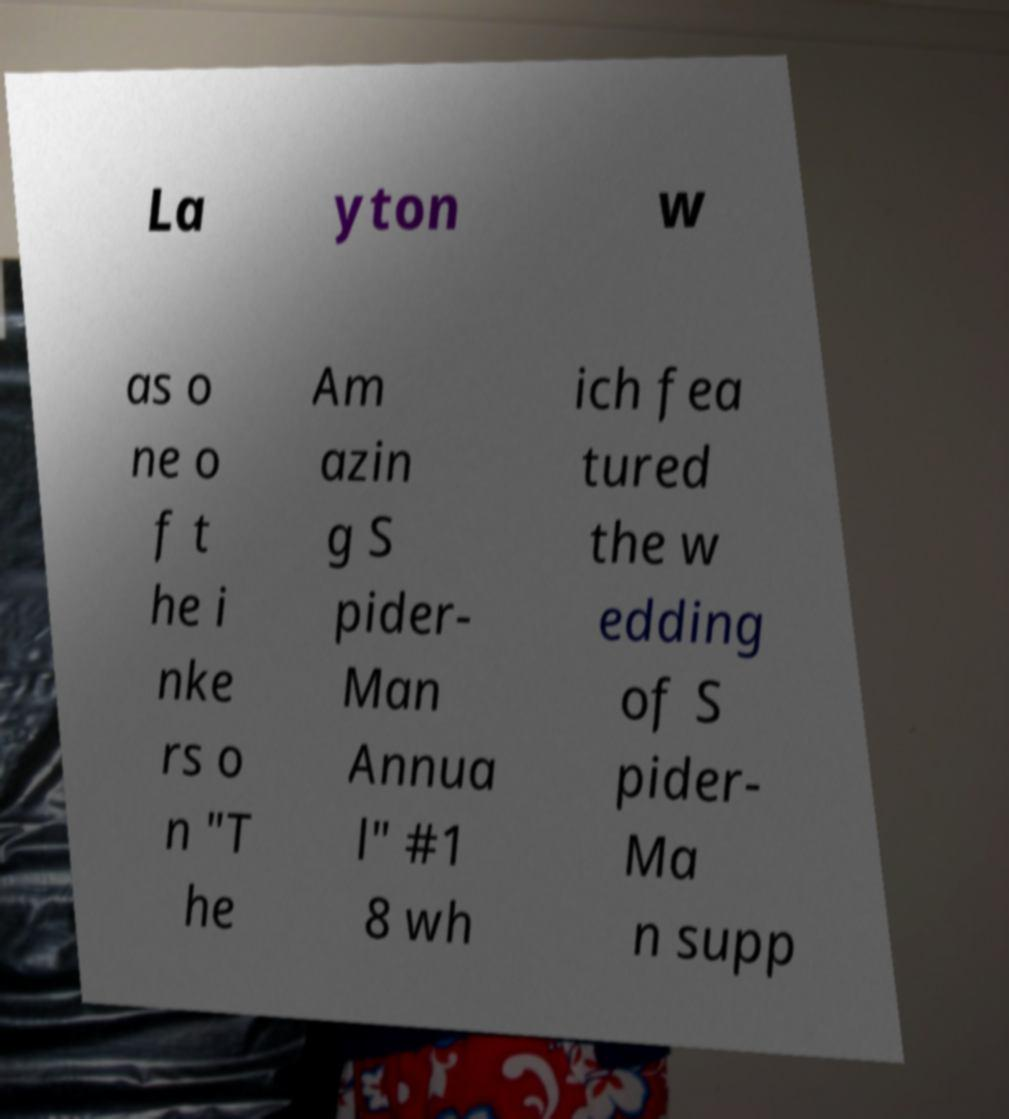Can you read and provide the text displayed in the image?This photo seems to have some interesting text. Can you extract and type it out for me? La yton w as o ne o f t he i nke rs o n "T he Am azin g S pider- Man Annua l" #1 8 wh ich fea tured the w edding of S pider- Ma n supp 